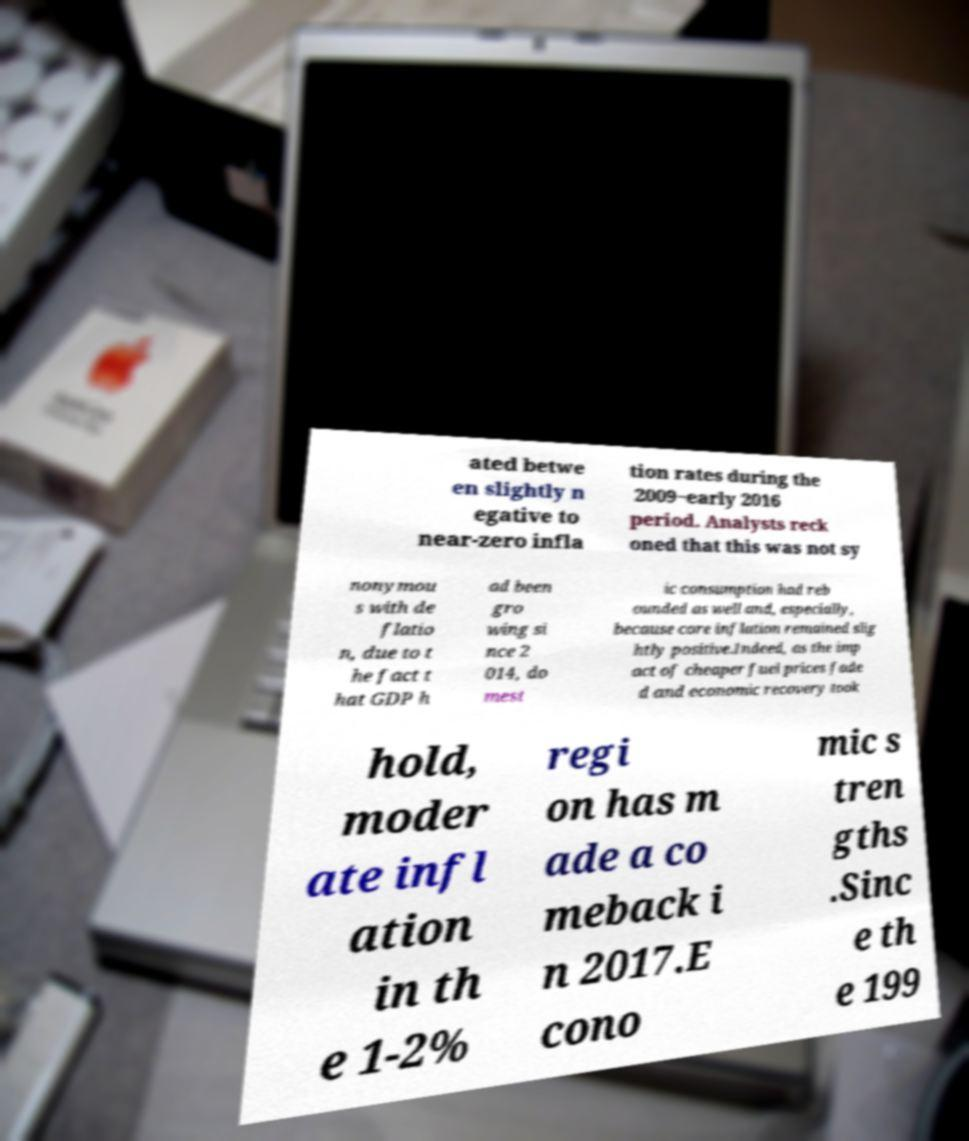Please identify and transcribe the text found in this image. ated betwe en slightly n egative to near-zero infla tion rates during the 2009−early 2016 period. Analysts reck oned that this was not sy nonymou s with de flatio n, due to t he fact t hat GDP h ad been gro wing si nce 2 014, do mest ic consumption had reb ounded as well and, especially, because core inflation remained slig htly positive.Indeed, as the imp act of cheaper fuel prices fade d and economic recovery took hold, moder ate infl ation in th e 1-2% regi on has m ade a co meback i n 2017.E cono mic s tren gths .Sinc e th e 199 